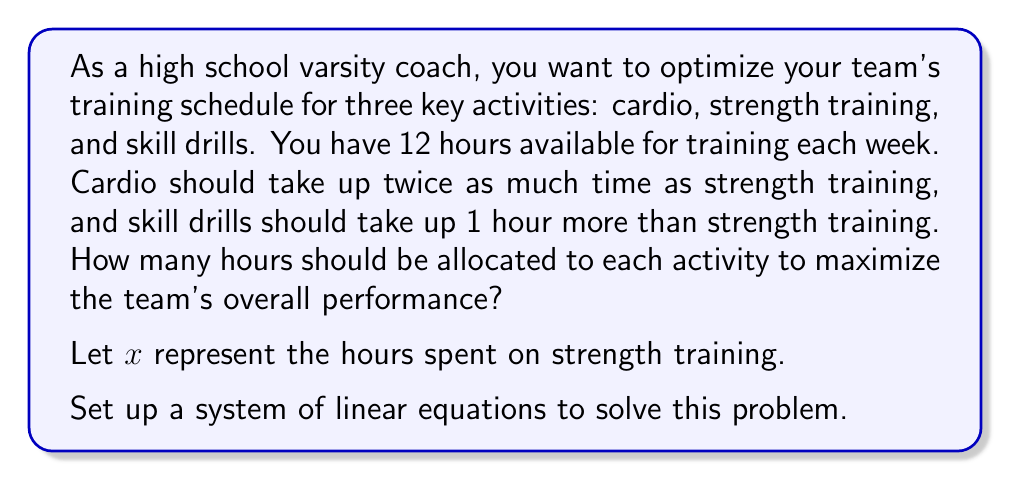Teach me how to tackle this problem. Let's approach this step-by-step:

1) Define variables:
   $x$ = hours spent on strength training
   $2x$ = hours spent on cardio (twice as much as strength training)
   $x + 1$ = hours spent on skill drills (1 hour more than strength training)

2) Set up the equation based on the total available time:
   $x + 2x + (x + 1) = 12$

3) Simplify the equation:
   $4x + 1 = 12$

4) Solve for $x$:
   $4x = 11$
   $x = \frac{11}{4} = 2.75$

5) Calculate the time for each activity:
   Strength training: $x = 2.75$ hours
   Cardio: $2x = 2(2.75) = 5.5$ hours
   Skill drills: $x + 1 = 2.75 + 1 = 3.75$ hours

6) Verify the total:
   $2.75 + 5.5 + 3.75 = 12$ hours

Therefore, the optimal training schedule allocates:
- 2.75 hours for strength training
- 5.5 hours for cardio
- 3.75 hours for skill drills
Answer: Strength training: 2.75 hours, Cardio: 5.5 hours, Skill drills: 3.75 hours 